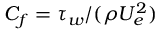Convert formula to latex. <formula><loc_0><loc_0><loc_500><loc_500>C _ { f } = \tau _ { w } / ( \rho U _ { e } ^ { 2 } )</formula> 